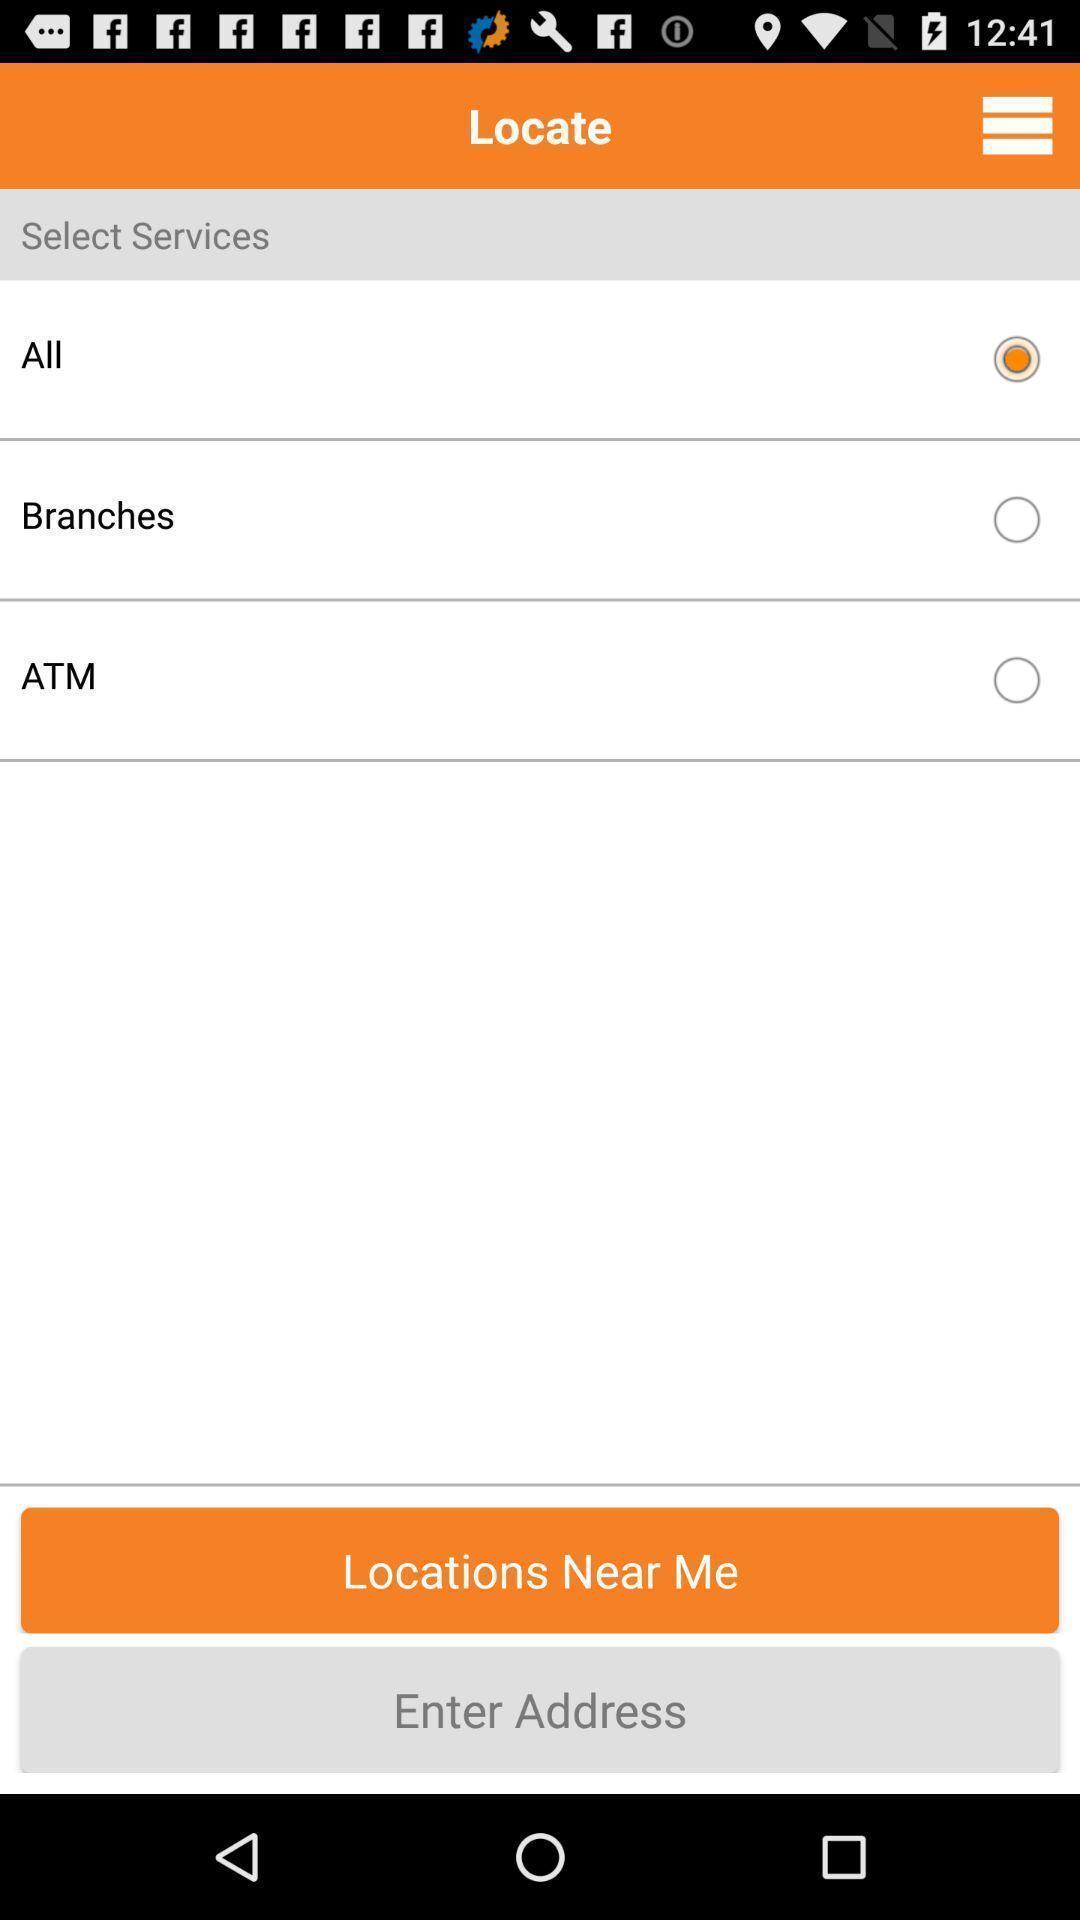Summarize the information in this screenshot. Page showing bank services to locate near me. 